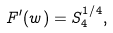<formula> <loc_0><loc_0><loc_500><loc_500>F ^ { \prime } ( w ) = S _ { 4 } ^ { 1 / 4 } ,</formula> 